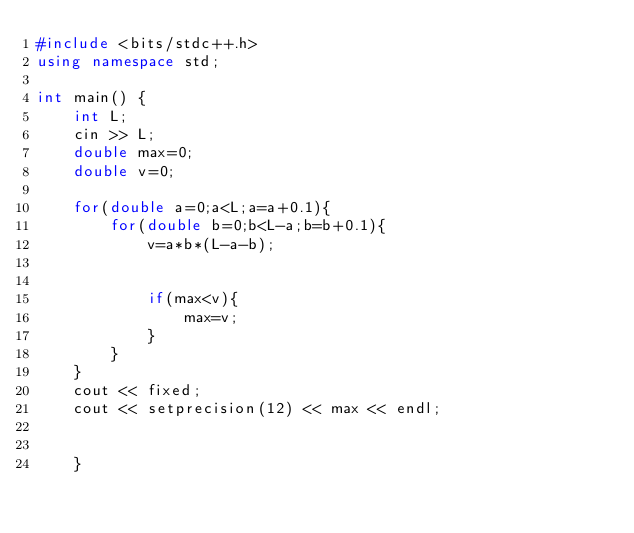<code> <loc_0><loc_0><loc_500><loc_500><_C++_>#include <bits/stdc++.h>
using namespace std;
 
int main() {
    int L;
    cin >> L;
    double max=0;
    double v=0;
    
    for(double a=0;a<L;a=a+0.1){
        for(double b=0;b<L-a;b=b+0.1){
            v=a*b*(L-a-b);
            
            
            if(max<v){
                max=v;
            }
        }
    }
    cout << fixed;
    cout << setprecision(12) << max << endl;
    
    
    }
</code> 